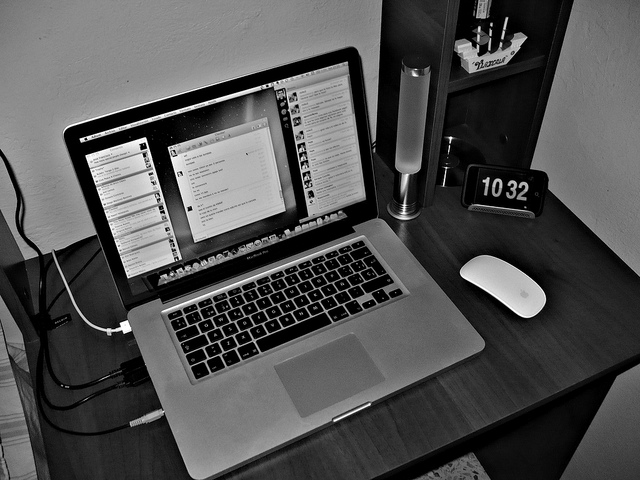Identify the text contained in this image. 10 32 